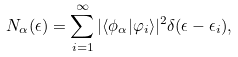Convert formula to latex. <formula><loc_0><loc_0><loc_500><loc_500>N _ { \alpha } ( \epsilon ) = \sum _ { i = 1 } ^ { \infty } | \langle \phi _ { \alpha } | \varphi _ { i } \rangle | ^ { 2 } \delta ( \epsilon - \epsilon _ { i } ) ,</formula> 